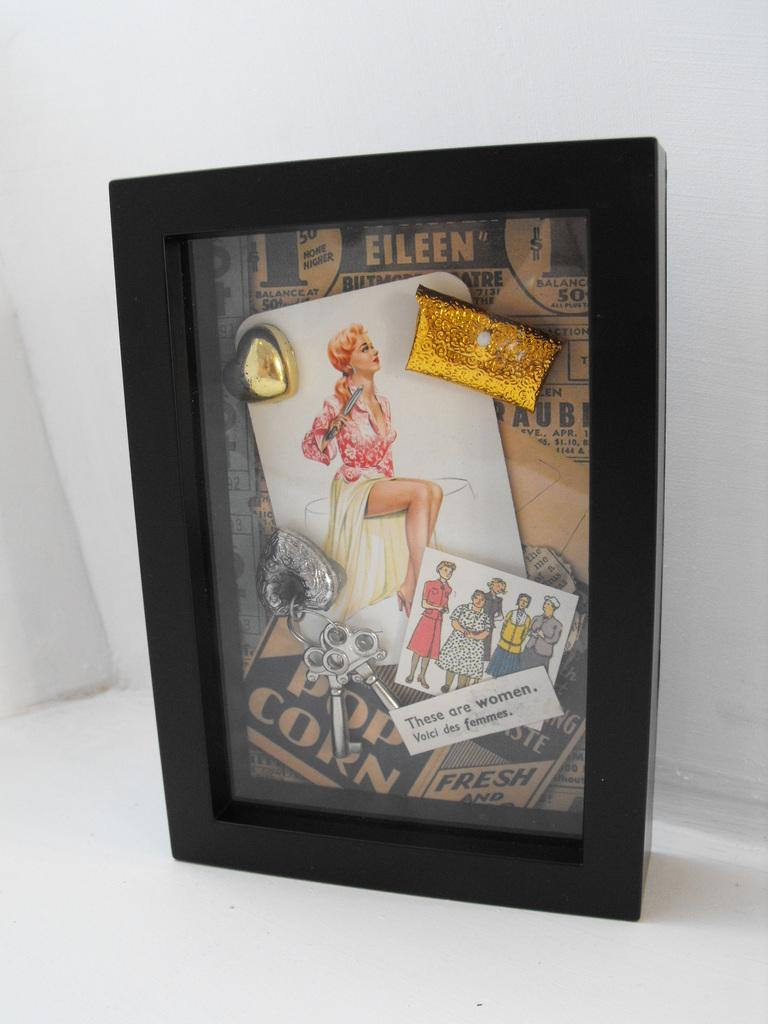<image>
Provide a brief description of the given image. A shadow box display with a pop corn advertisement 